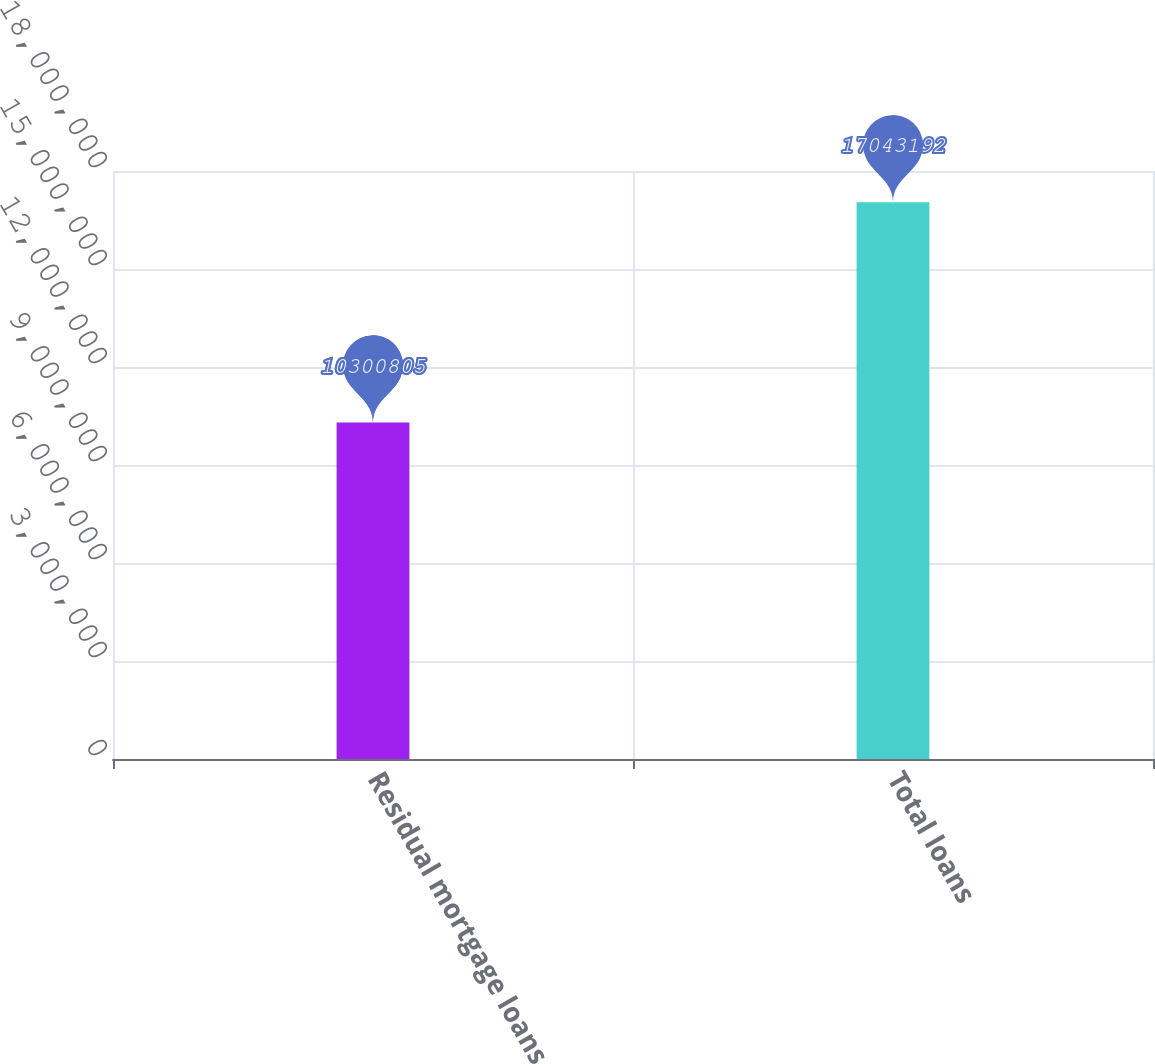<chart> <loc_0><loc_0><loc_500><loc_500><bar_chart><fcel>Residual mortgage loans<fcel>Total loans<nl><fcel>1.03008e+07<fcel>1.70432e+07<nl></chart> 